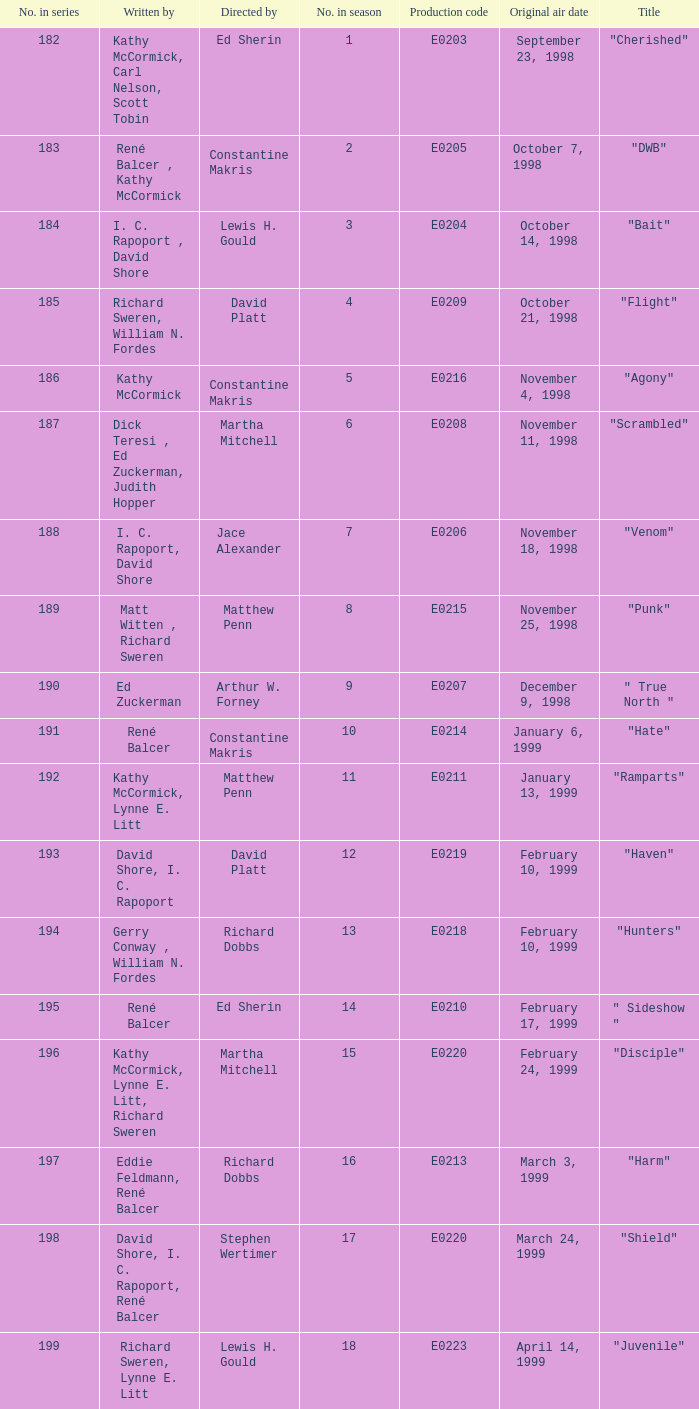On october 21, 1998, what was the title of the episode that first premiered? "Flight". 